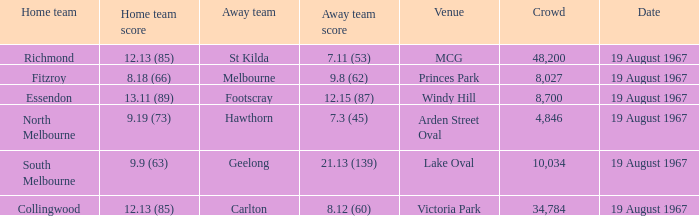3 (45), what was the score for the home team? 9.19 (73). 